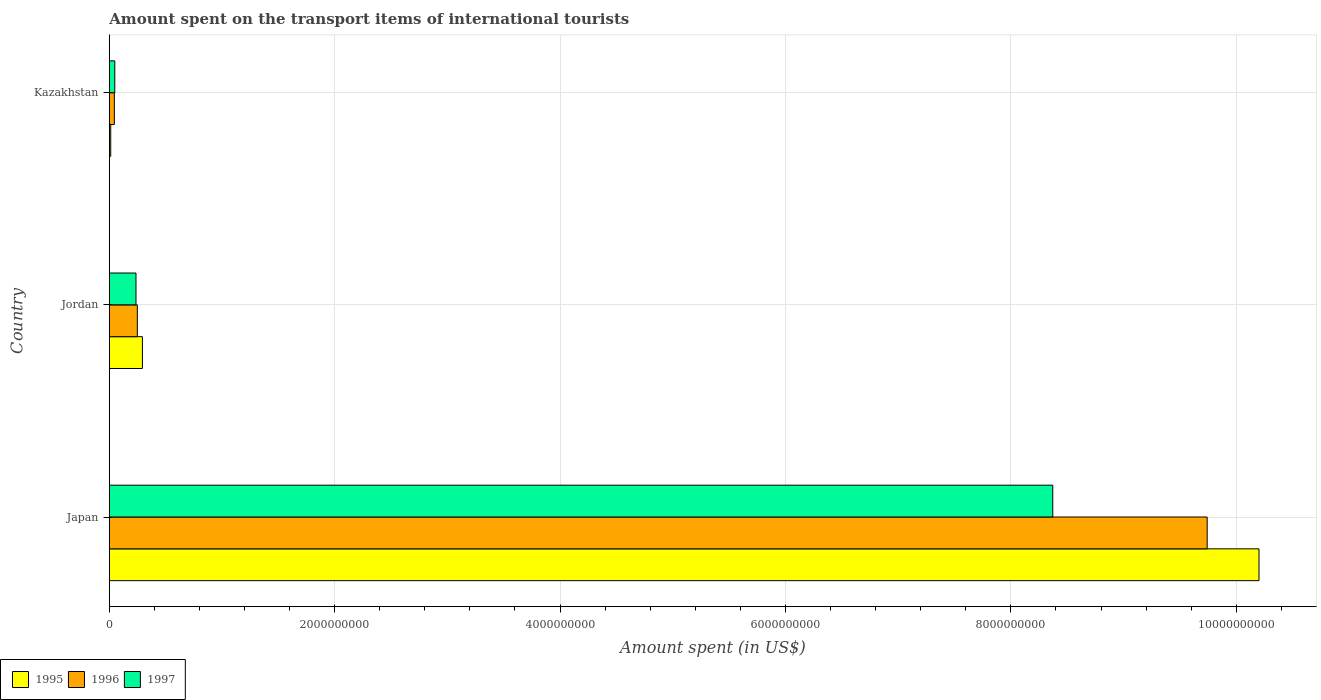How many different coloured bars are there?
Provide a short and direct response. 3. How many groups of bars are there?
Ensure brevity in your answer.  3. Are the number of bars on each tick of the Y-axis equal?
Keep it short and to the point. Yes. How many bars are there on the 1st tick from the bottom?
Your answer should be compact. 3. What is the label of the 1st group of bars from the top?
Ensure brevity in your answer.  Kazakhstan. In how many cases, is the number of bars for a given country not equal to the number of legend labels?
Provide a succinct answer. 0. What is the amount spent on the transport items of international tourists in 1996 in Kazakhstan?
Provide a succinct answer. 4.50e+07. Across all countries, what is the maximum amount spent on the transport items of international tourists in 1996?
Make the answer very short. 9.74e+09. Across all countries, what is the minimum amount spent on the transport items of international tourists in 1996?
Your response must be concise. 4.50e+07. In which country was the amount spent on the transport items of international tourists in 1997 maximum?
Ensure brevity in your answer.  Japan. In which country was the amount spent on the transport items of international tourists in 1997 minimum?
Provide a short and direct response. Kazakhstan. What is the total amount spent on the transport items of international tourists in 1995 in the graph?
Provide a short and direct response. 1.05e+1. What is the difference between the amount spent on the transport items of international tourists in 1995 in Japan and that in Jordan?
Make the answer very short. 9.91e+09. What is the difference between the amount spent on the transport items of international tourists in 1995 in Jordan and the amount spent on the transport items of international tourists in 1997 in Kazakhstan?
Make the answer very short. 2.45e+08. What is the average amount spent on the transport items of international tourists in 1995 per country?
Give a very brief answer. 3.50e+09. What is the difference between the amount spent on the transport items of international tourists in 1996 and amount spent on the transport items of international tourists in 1995 in Jordan?
Offer a very short reply. -4.50e+07. What is the ratio of the amount spent on the transport items of international tourists in 1995 in Japan to that in Kazakhstan?
Give a very brief answer. 784.77. Is the amount spent on the transport items of international tourists in 1997 in Japan less than that in Jordan?
Your answer should be very brief. No. What is the difference between the highest and the second highest amount spent on the transport items of international tourists in 1995?
Offer a very short reply. 9.91e+09. What is the difference between the highest and the lowest amount spent on the transport items of international tourists in 1996?
Your response must be concise. 9.70e+09. In how many countries, is the amount spent on the transport items of international tourists in 1995 greater than the average amount spent on the transport items of international tourists in 1995 taken over all countries?
Offer a very short reply. 1. What does the 3rd bar from the top in Jordan represents?
Offer a very short reply. 1995. Is it the case that in every country, the sum of the amount spent on the transport items of international tourists in 1997 and amount spent on the transport items of international tourists in 1995 is greater than the amount spent on the transport items of international tourists in 1996?
Your answer should be very brief. Yes. Are all the bars in the graph horizontal?
Offer a very short reply. Yes. Are the values on the major ticks of X-axis written in scientific E-notation?
Offer a very short reply. No. Does the graph contain any zero values?
Keep it short and to the point. No. Does the graph contain grids?
Provide a short and direct response. Yes. Where does the legend appear in the graph?
Provide a short and direct response. Bottom left. What is the title of the graph?
Give a very brief answer. Amount spent on the transport items of international tourists. Does "1973" appear as one of the legend labels in the graph?
Offer a very short reply. No. What is the label or title of the X-axis?
Keep it short and to the point. Amount spent (in US$). What is the label or title of the Y-axis?
Offer a terse response. Country. What is the Amount spent (in US$) of 1995 in Japan?
Offer a terse response. 1.02e+1. What is the Amount spent (in US$) of 1996 in Japan?
Keep it short and to the point. 9.74e+09. What is the Amount spent (in US$) of 1997 in Japan?
Offer a terse response. 8.37e+09. What is the Amount spent (in US$) of 1995 in Jordan?
Offer a very short reply. 2.94e+08. What is the Amount spent (in US$) in 1996 in Jordan?
Your response must be concise. 2.49e+08. What is the Amount spent (in US$) in 1997 in Jordan?
Keep it short and to the point. 2.37e+08. What is the Amount spent (in US$) in 1995 in Kazakhstan?
Keep it short and to the point. 1.30e+07. What is the Amount spent (in US$) of 1996 in Kazakhstan?
Make the answer very short. 4.50e+07. What is the Amount spent (in US$) in 1997 in Kazakhstan?
Offer a very short reply. 4.90e+07. Across all countries, what is the maximum Amount spent (in US$) of 1995?
Ensure brevity in your answer.  1.02e+1. Across all countries, what is the maximum Amount spent (in US$) of 1996?
Offer a very short reply. 9.74e+09. Across all countries, what is the maximum Amount spent (in US$) in 1997?
Your answer should be very brief. 8.37e+09. Across all countries, what is the minimum Amount spent (in US$) in 1995?
Ensure brevity in your answer.  1.30e+07. Across all countries, what is the minimum Amount spent (in US$) of 1996?
Keep it short and to the point. 4.50e+07. Across all countries, what is the minimum Amount spent (in US$) in 1997?
Provide a succinct answer. 4.90e+07. What is the total Amount spent (in US$) in 1995 in the graph?
Your response must be concise. 1.05e+1. What is the total Amount spent (in US$) in 1996 in the graph?
Make the answer very short. 1.00e+1. What is the total Amount spent (in US$) of 1997 in the graph?
Your answer should be compact. 8.66e+09. What is the difference between the Amount spent (in US$) of 1995 in Japan and that in Jordan?
Make the answer very short. 9.91e+09. What is the difference between the Amount spent (in US$) in 1996 in Japan and that in Jordan?
Ensure brevity in your answer.  9.49e+09. What is the difference between the Amount spent (in US$) in 1997 in Japan and that in Jordan?
Your answer should be compact. 8.14e+09. What is the difference between the Amount spent (in US$) in 1995 in Japan and that in Kazakhstan?
Your answer should be very brief. 1.02e+1. What is the difference between the Amount spent (in US$) of 1996 in Japan and that in Kazakhstan?
Keep it short and to the point. 9.70e+09. What is the difference between the Amount spent (in US$) in 1997 in Japan and that in Kazakhstan?
Make the answer very short. 8.32e+09. What is the difference between the Amount spent (in US$) in 1995 in Jordan and that in Kazakhstan?
Offer a very short reply. 2.81e+08. What is the difference between the Amount spent (in US$) of 1996 in Jordan and that in Kazakhstan?
Make the answer very short. 2.04e+08. What is the difference between the Amount spent (in US$) in 1997 in Jordan and that in Kazakhstan?
Offer a very short reply. 1.88e+08. What is the difference between the Amount spent (in US$) in 1995 in Japan and the Amount spent (in US$) in 1996 in Jordan?
Keep it short and to the point. 9.95e+09. What is the difference between the Amount spent (in US$) in 1995 in Japan and the Amount spent (in US$) in 1997 in Jordan?
Offer a terse response. 9.96e+09. What is the difference between the Amount spent (in US$) of 1996 in Japan and the Amount spent (in US$) of 1997 in Jordan?
Provide a short and direct response. 9.50e+09. What is the difference between the Amount spent (in US$) of 1995 in Japan and the Amount spent (in US$) of 1996 in Kazakhstan?
Make the answer very short. 1.02e+1. What is the difference between the Amount spent (in US$) of 1995 in Japan and the Amount spent (in US$) of 1997 in Kazakhstan?
Your response must be concise. 1.02e+1. What is the difference between the Amount spent (in US$) of 1996 in Japan and the Amount spent (in US$) of 1997 in Kazakhstan?
Provide a short and direct response. 9.69e+09. What is the difference between the Amount spent (in US$) of 1995 in Jordan and the Amount spent (in US$) of 1996 in Kazakhstan?
Your response must be concise. 2.49e+08. What is the difference between the Amount spent (in US$) of 1995 in Jordan and the Amount spent (in US$) of 1997 in Kazakhstan?
Offer a very short reply. 2.45e+08. What is the average Amount spent (in US$) of 1995 per country?
Offer a terse response. 3.50e+09. What is the average Amount spent (in US$) in 1996 per country?
Your response must be concise. 3.35e+09. What is the average Amount spent (in US$) of 1997 per country?
Offer a terse response. 2.89e+09. What is the difference between the Amount spent (in US$) of 1995 and Amount spent (in US$) of 1996 in Japan?
Keep it short and to the point. 4.60e+08. What is the difference between the Amount spent (in US$) in 1995 and Amount spent (in US$) in 1997 in Japan?
Your response must be concise. 1.83e+09. What is the difference between the Amount spent (in US$) of 1996 and Amount spent (in US$) of 1997 in Japan?
Provide a succinct answer. 1.37e+09. What is the difference between the Amount spent (in US$) in 1995 and Amount spent (in US$) in 1996 in Jordan?
Offer a very short reply. 4.50e+07. What is the difference between the Amount spent (in US$) of 1995 and Amount spent (in US$) of 1997 in Jordan?
Your response must be concise. 5.70e+07. What is the difference between the Amount spent (in US$) in 1995 and Amount spent (in US$) in 1996 in Kazakhstan?
Your response must be concise. -3.20e+07. What is the difference between the Amount spent (in US$) of 1995 and Amount spent (in US$) of 1997 in Kazakhstan?
Offer a terse response. -3.60e+07. What is the ratio of the Amount spent (in US$) in 1995 in Japan to that in Jordan?
Keep it short and to the point. 34.7. What is the ratio of the Amount spent (in US$) in 1996 in Japan to that in Jordan?
Keep it short and to the point. 39.12. What is the ratio of the Amount spent (in US$) of 1997 in Japan to that in Jordan?
Offer a terse response. 35.32. What is the ratio of the Amount spent (in US$) in 1995 in Japan to that in Kazakhstan?
Your answer should be compact. 784.77. What is the ratio of the Amount spent (in US$) of 1996 in Japan to that in Kazakhstan?
Your response must be concise. 216.49. What is the ratio of the Amount spent (in US$) in 1997 in Japan to that in Kazakhstan?
Offer a very short reply. 170.86. What is the ratio of the Amount spent (in US$) in 1995 in Jordan to that in Kazakhstan?
Give a very brief answer. 22.62. What is the ratio of the Amount spent (in US$) in 1996 in Jordan to that in Kazakhstan?
Your answer should be compact. 5.53. What is the ratio of the Amount spent (in US$) of 1997 in Jordan to that in Kazakhstan?
Offer a very short reply. 4.84. What is the difference between the highest and the second highest Amount spent (in US$) in 1995?
Your response must be concise. 9.91e+09. What is the difference between the highest and the second highest Amount spent (in US$) in 1996?
Ensure brevity in your answer.  9.49e+09. What is the difference between the highest and the second highest Amount spent (in US$) in 1997?
Your answer should be compact. 8.14e+09. What is the difference between the highest and the lowest Amount spent (in US$) of 1995?
Your response must be concise. 1.02e+1. What is the difference between the highest and the lowest Amount spent (in US$) of 1996?
Provide a succinct answer. 9.70e+09. What is the difference between the highest and the lowest Amount spent (in US$) in 1997?
Ensure brevity in your answer.  8.32e+09. 